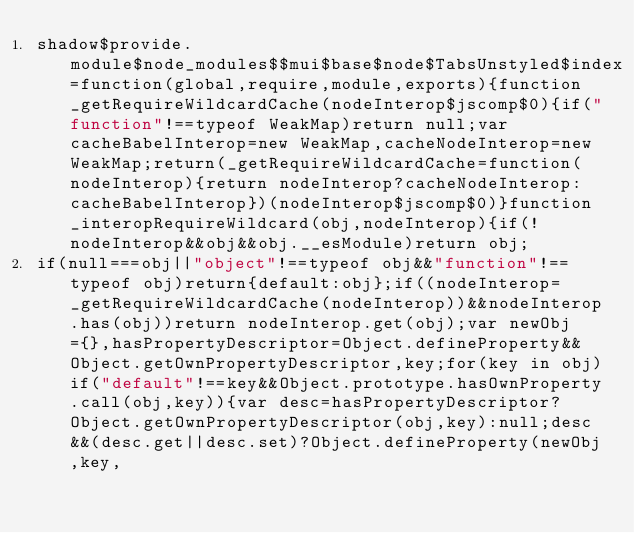<code> <loc_0><loc_0><loc_500><loc_500><_JavaScript_>shadow$provide.module$node_modules$$mui$base$node$TabsUnstyled$index=function(global,require,module,exports){function _getRequireWildcardCache(nodeInterop$jscomp$0){if("function"!==typeof WeakMap)return null;var cacheBabelInterop=new WeakMap,cacheNodeInterop=new WeakMap;return(_getRequireWildcardCache=function(nodeInterop){return nodeInterop?cacheNodeInterop:cacheBabelInterop})(nodeInterop$jscomp$0)}function _interopRequireWildcard(obj,nodeInterop){if(!nodeInterop&&obj&&obj.__esModule)return obj;
if(null===obj||"object"!==typeof obj&&"function"!==typeof obj)return{default:obj};if((nodeInterop=_getRequireWildcardCache(nodeInterop))&&nodeInterop.has(obj))return nodeInterop.get(obj);var newObj={},hasPropertyDescriptor=Object.defineProperty&&Object.getOwnPropertyDescriptor,key;for(key in obj)if("default"!==key&&Object.prototype.hasOwnProperty.call(obj,key)){var desc=hasPropertyDescriptor?Object.getOwnPropertyDescriptor(obj,key):null;desc&&(desc.get||desc.set)?Object.defineProperty(newObj,key,</code> 